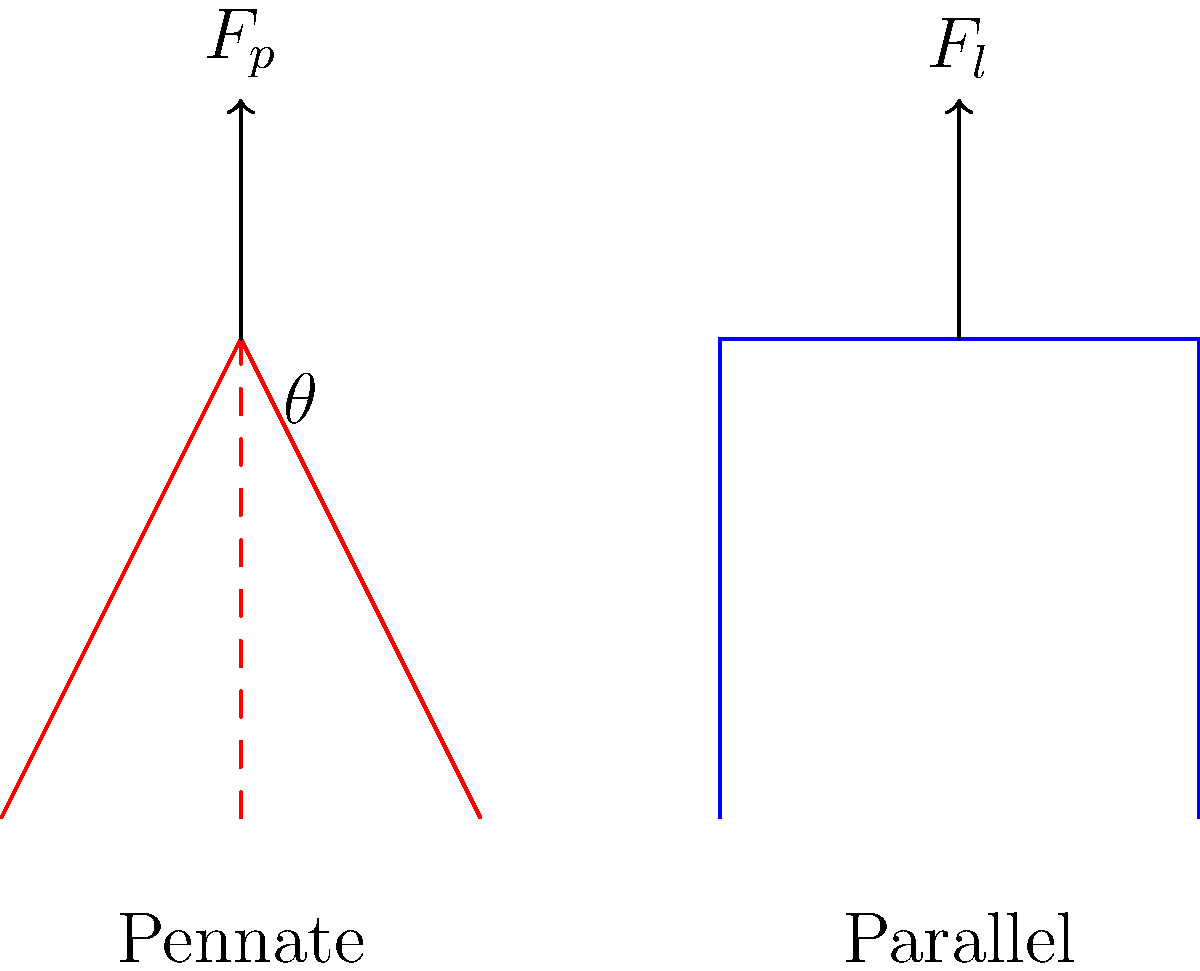In the context of muscle fiber orientation, compare the force output of pennate and parallel muscle fibers. How does the programming concept of modular design relate to the efficiency of these muscle arrangements? To compare the force output of pennate and parallel muscle fibers, we need to consider their orientations and how they affect force transmission:

1. Parallel fibers:
   - Fibers are aligned with the direction of muscle contraction
   - Force output ($F_l$) is directly proportional to the number of fibers
   - Equation: $F_l = F_{max} \cdot n$, where $F_{max}$ is the maximum force per fiber, and $n$ is the number of fibers

2. Pennate fibers:
   - Fibers are oriented at an angle ($\theta$) to the direction of muscle contraction
   - Force output ($F_p$) is reduced due to the angular orientation
   - Equation: $F_p = F_{max} \cdot n \cdot \cos(\theta)$

3. Comparison:
   - For the same number of fibers, parallel arrangement produces more force: $F_l > F_p$
   - However, pennate arrangement allows more fibers to be packed in the same volume, potentially increasing overall force

4. Efficiency trade-offs:
   - Parallel: Higher force output per fiber, but limited fiber quantity
   - Pennate: Lower force output per fiber, but higher fiber quantity possible

5. Relation to modular design in programming:
   - Parallel fibers are like simple, direct function calls
   - Pennate fibers are like modular components with interfaces (angle $\theta$)
   - Pennate arrangement sacrifices some efficiency for increased functionality (more fibers)
   - This is similar to how modular design in programming may introduce some overhead but allows for greater flexibility and scalability

In both muscle design and programming, the choice between direct (parallel) and modular (pennate) approaches depends on specific requirements and trade-offs between efficiency and functionality.
Answer: Parallel fibers produce more force per fiber, but pennate arrangement allows more fibers in the same volume, potentially increasing overall force. This trade-off mirrors the balance between efficiency and modularity in programming language design. 